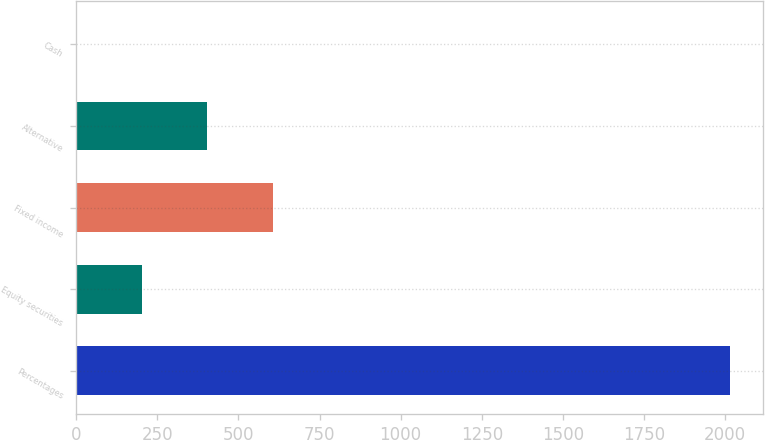<chart> <loc_0><loc_0><loc_500><loc_500><bar_chart><fcel>Percentages<fcel>Equity securities<fcel>Fixed income<fcel>Alternative<fcel>Cash<nl><fcel>2016<fcel>203.4<fcel>606.2<fcel>404.8<fcel>2<nl></chart> 